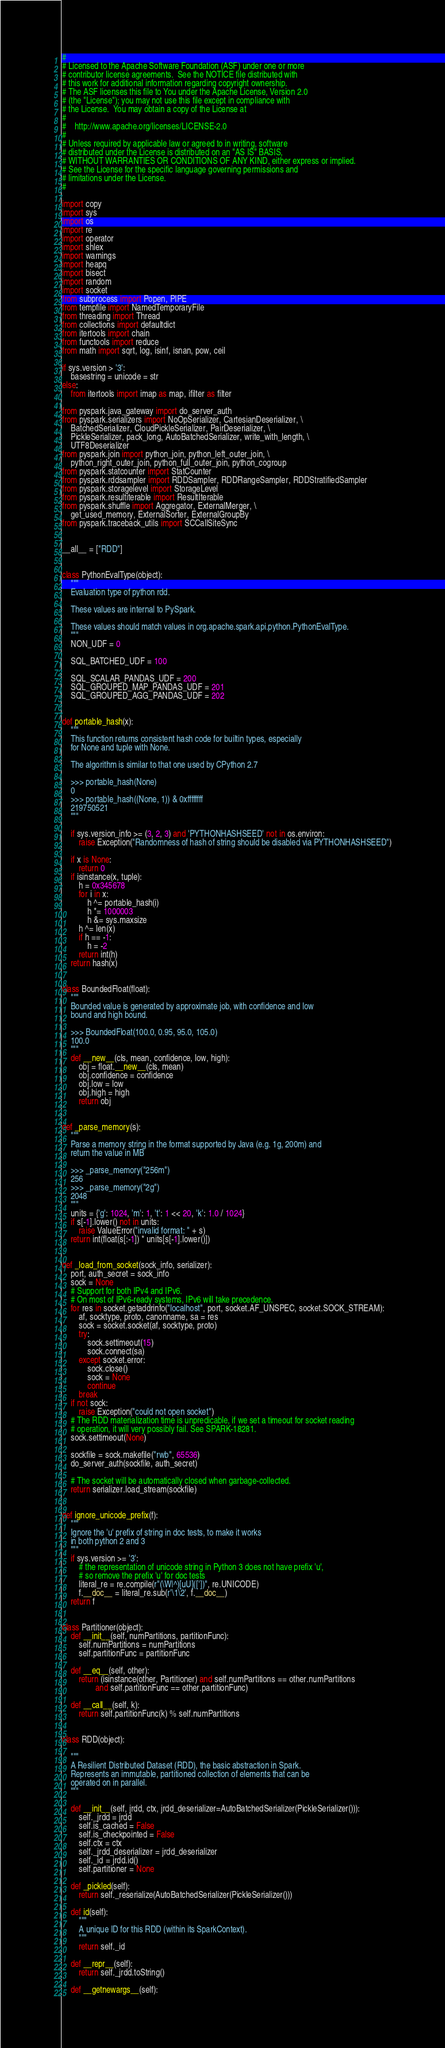<code> <loc_0><loc_0><loc_500><loc_500><_Python_>#
# Licensed to the Apache Software Foundation (ASF) under one or more
# contributor license agreements.  See the NOTICE file distributed with
# this work for additional information regarding copyright ownership.
# The ASF licenses this file to You under the Apache License, Version 2.0
# (the "License"); you may not use this file except in compliance with
# the License.  You may obtain a copy of the License at
#
#    http://www.apache.org/licenses/LICENSE-2.0
#
# Unless required by applicable law or agreed to in writing, software
# distributed under the License is distributed on an "AS IS" BASIS,
# WITHOUT WARRANTIES OR CONDITIONS OF ANY KIND, either express or implied.
# See the License for the specific language governing permissions and
# limitations under the License.
#

import copy
import sys
import os
import re
import operator
import shlex
import warnings
import heapq
import bisect
import random
import socket
from subprocess import Popen, PIPE
from tempfile import NamedTemporaryFile
from threading import Thread
from collections import defaultdict
from itertools import chain
from functools import reduce
from math import sqrt, log, isinf, isnan, pow, ceil

if sys.version > '3':
    basestring = unicode = str
else:
    from itertools import imap as map, ifilter as filter

from pyspark.java_gateway import do_server_auth
from pyspark.serializers import NoOpSerializer, CartesianDeserializer, \
    BatchedSerializer, CloudPickleSerializer, PairDeserializer, \
    PickleSerializer, pack_long, AutoBatchedSerializer, write_with_length, \
    UTF8Deserializer
from pyspark.join import python_join, python_left_outer_join, \
    python_right_outer_join, python_full_outer_join, python_cogroup
from pyspark.statcounter import StatCounter
from pyspark.rddsampler import RDDSampler, RDDRangeSampler, RDDStratifiedSampler
from pyspark.storagelevel import StorageLevel
from pyspark.resultiterable import ResultIterable
from pyspark.shuffle import Aggregator, ExternalMerger, \
    get_used_memory, ExternalSorter, ExternalGroupBy
from pyspark.traceback_utils import SCCallSiteSync


__all__ = ["RDD"]


class PythonEvalType(object):
    """
    Evaluation type of python rdd.

    These values are internal to PySpark.

    These values should match values in org.apache.spark.api.python.PythonEvalType.
    """
    NON_UDF = 0

    SQL_BATCHED_UDF = 100

    SQL_SCALAR_PANDAS_UDF = 200
    SQL_GROUPED_MAP_PANDAS_UDF = 201
    SQL_GROUPED_AGG_PANDAS_UDF = 202


def portable_hash(x):
    """
    This function returns consistent hash code for builtin types, especially
    for None and tuple with None.

    The algorithm is similar to that one used by CPython 2.7

    >>> portable_hash(None)
    0
    >>> portable_hash((None, 1)) & 0xffffffff
    219750521
    """

    if sys.version_info >= (3, 2, 3) and 'PYTHONHASHSEED' not in os.environ:
        raise Exception("Randomness of hash of string should be disabled via PYTHONHASHSEED")

    if x is None:
        return 0
    if isinstance(x, tuple):
        h = 0x345678
        for i in x:
            h ^= portable_hash(i)
            h *= 1000003
            h &= sys.maxsize
        h ^= len(x)
        if h == -1:
            h = -2
        return int(h)
    return hash(x)


class BoundedFloat(float):
    """
    Bounded value is generated by approximate job, with confidence and low
    bound and high bound.

    >>> BoundedFloat(100.0, 0.95, 95.0, 105.0)
    100.0
    """
    def __new__(cls, mean, confidence, low, high):
        obj = float.__new__(cls, mean)
        obj.confidence = confidence
        obj.low = low
        obj.high = high
        return obj


def _parse_memory(s):
    """
    Parse a memory string in the format supported by Java (e.g. 1g, 200m) and
    return the value in MB

    >>> _parse_memory("256m")
    256
    >>> _parse_memory("2g")
    2048
    """
    units = {'g': 1024, 'm': 1, 't': 1 << 20, 'k': 1.0 / 1024}
    if s[-1].lower() not in units:
        raise ValueError("invalid format: " + s)
    return int(float(s[:-1]) * units[s[-1].lower()])


def _load_from_socket(sock_info, serializer):
    port, auth_secret = sock_info
    sock = None
    # Support for both IPv4 and IPv6.
    # On most of IPv6-ready systems, IPv6 will take precedence.
    for res in socket.getaddrinfo("localhost", port, socket.AF_UNSPEC, socket.SOCK_STREAM):
        af, socktype, proto, canonname, sa = res
        sock = socket.socket(af, socktype, proto)
        try:
            sock.settimeout(15)
            sock.connect(sa)
        except socket.error:
            sock.close()
            sock = None
            continue
        break
    if not sock:
        raise Exception("could not open socket")
    # The RDD materialization time is unpredicable, if we set a timeout for socket reading
    # operation, it will very possibly fail. See SPARK-18281.
    sock.settimeout(None)

    sockfile = sock.makefile("rwb", 65536)
    do_server_auth(sockfile, auth_secret)

    # The socket will be automatically closed when garbage-collected.
    return serializer.load_stream(sockfile)


def ignore_unicode_prefix(f):
    """
    Ignore the 'u' prefix of string in doc tests, to make it works
    in both python 2 and 3
    """
    if sys.version >= '3':
        # the representation of unicode string in Python 3 does not have prefix 'u',
        # so remove the prefix 'u' for doc tests
        literal_re = re.compile(r"(\W|^)[uU](['])", re.UNICODE)
        f.__doc__ = literal_re.sub(r'\1\2', f.__doc__)
    return f


class Partitioner(object):
    def __init__(self, numPartitions, partitionFunc):
        self.numPartitions = numPartitions
        self.partitionFunc = partitionFunc

    def __eq__(self, other):
        return (isinstance(other, Partitioner) and self.numPartitions == other.numPartitions
                and self.partitionFunc == other.partitionFunc)

    def __call__(self, k):
        return self.partitionFunc(k) % self.numPartitions


class RDD(object):

    """
    A Resilient Distributed Dataset (RDD), the basic abstraction in Spark.
    Represents an immutable, partitioned collection of elements that can be
    operated on in parallel.
    """

    def __init__(self, jrdd, ctx, jrdd_deserializer=AutoBatchedSerializer(PickleSerializer())):
        self._jrdd = jrdd
        self.is_cached = False
        self.is_checkpointed = False
        self.ctx = ctx
        self._jrdd_deserializer = jrdd_deserializer
        self._id = jrdd.id()
        self.partitioner = None

    def _pickled(self):
        return self._reserialize(AutoBatchedSerializer(PickleSerializer()))

    def id(self):
        """
        A unique ID for this RDD (within its SparkContext).
        """
        return self._id

    def __repr__(self):
        return self._jrdd.toString()

    def __getnewargs__(self):</code> 